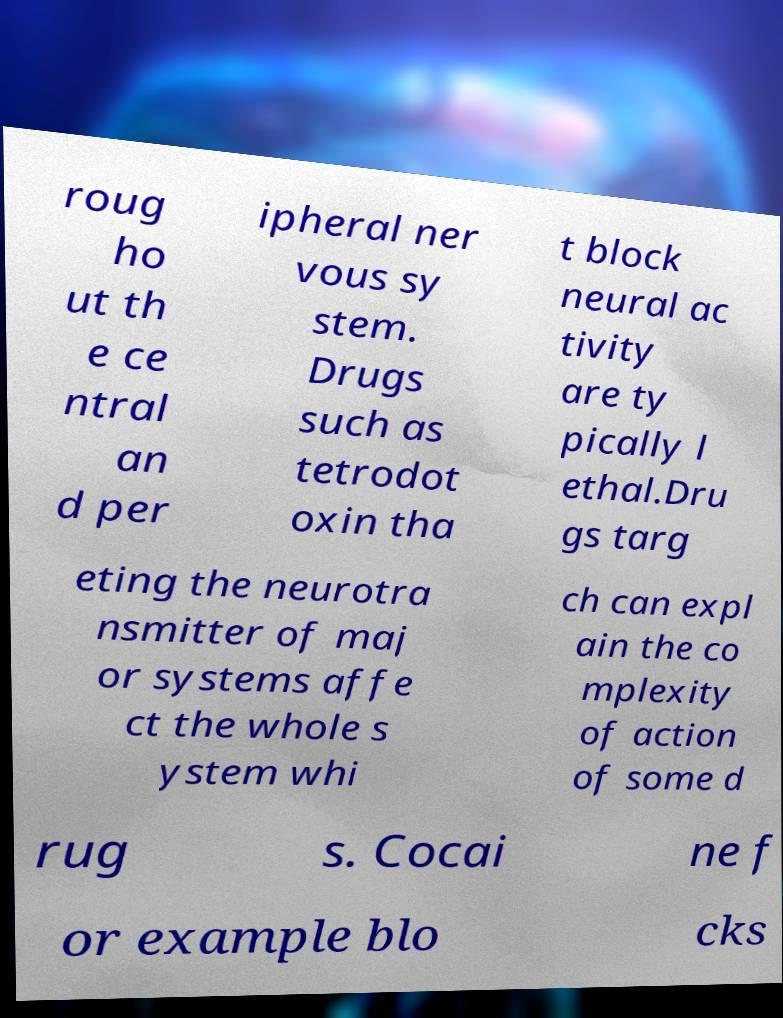For documentation purposes, I need the text within this image transcribed. Could you provide that? roug ho ut th e ce ntral an d per ipheral ner vous sy stem. Drugs such as tetrodot oxin tha t block neural ac tivity are ty pically l ethal.Dru gs targ eting the neurotra nsmitter of maj or systems affe ct the whole s ystem whi ch can expl ain the co mplexity of action of some d rug s. Cocai ne f or example blo cks 